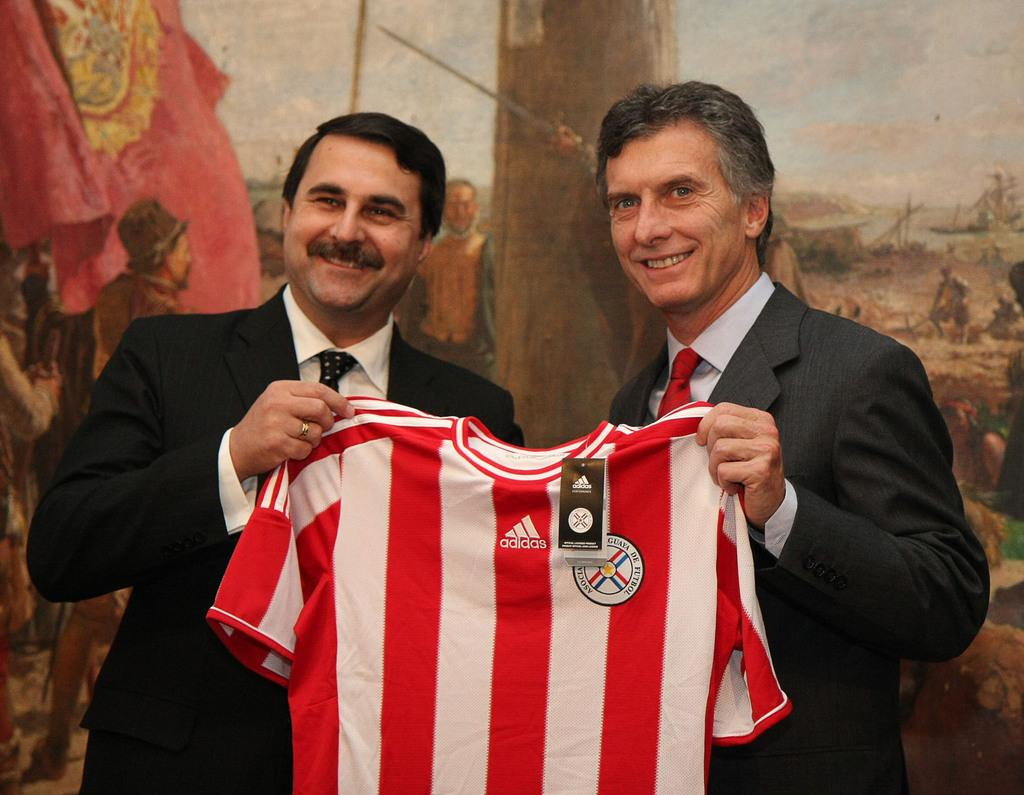<image>
Provide a brief description of the given image. Two men are holding up a red and white striped Adidas shirt. 